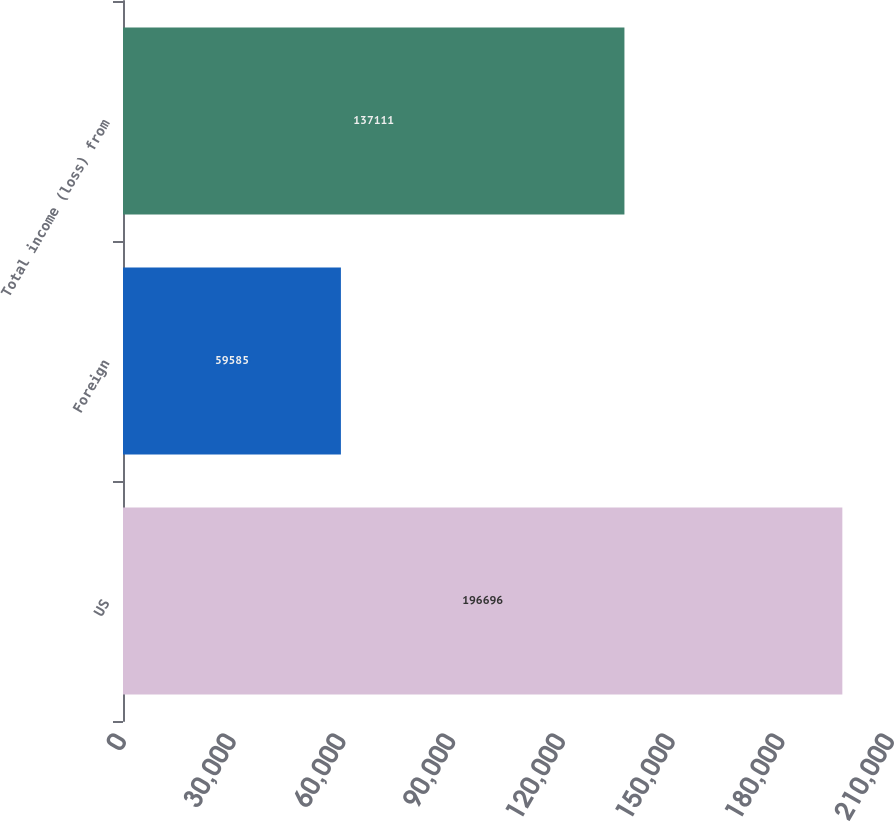<chart> <loc_0><loc_0><loc_500><loc_500><bar_chart><fcel>US<fcel>Foreign<fcel>Total income (loss) from<nl><fcel>196696<fcel>59585<fcel>137111<nl></chart> 